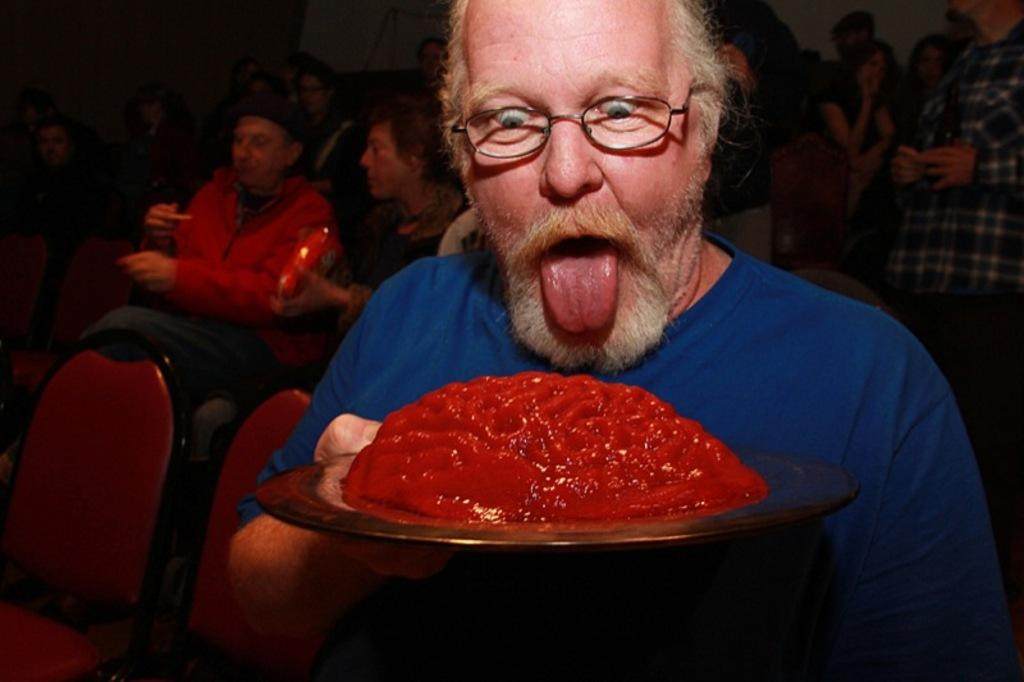Who is the main subject in the image? There is a man in the image. What is the man wearing? The man is wearing spectacles. What is the man holding in the image? The man is holding a plate. What is on the plate that the man is holding? There is food on the plate. What can be seen in the background of the image? There is a group of people and chairs in the background. What type of ink can be seen on the ground in the image? There is no ink or ground present in the image. How does the fire affect the man in the image? There is no fire present in the image. 